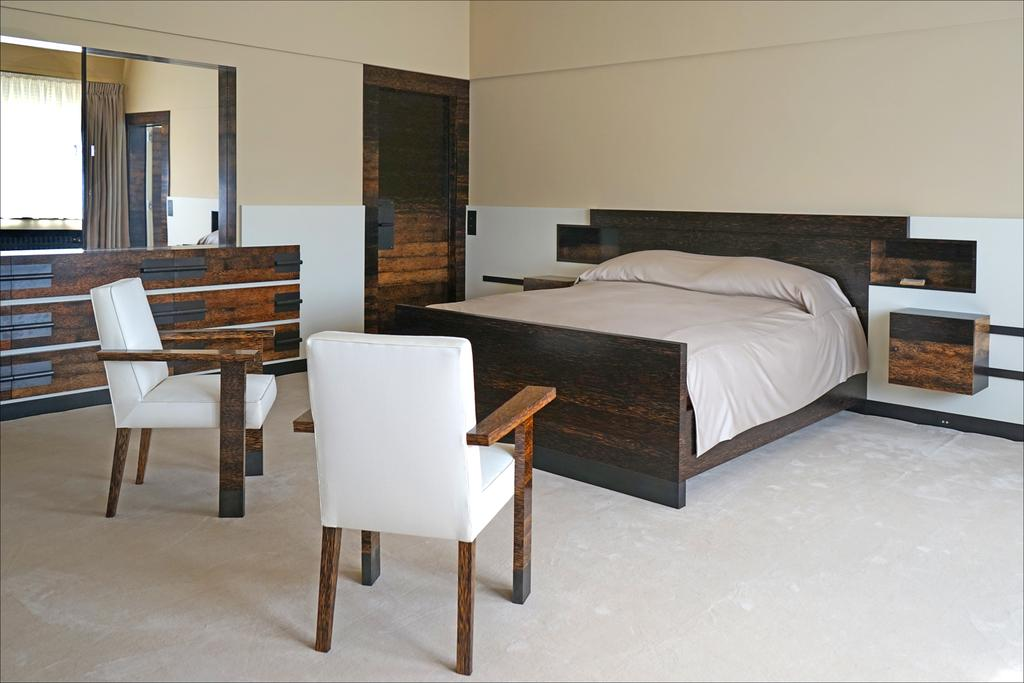What type of furniture is present in the image? There is a bed and 2 chairs in the image. What object might be used for personal grooming or checking appearance? There is a mirror in the image. What is a possible entrance or exit in the image? There is a door in the image. What architectural feature can be seen in the image? There is a wall in the image. What type of wood is used to build the yard in the image? There is no yard present in the image, and therefore no wood can be associated with it. 